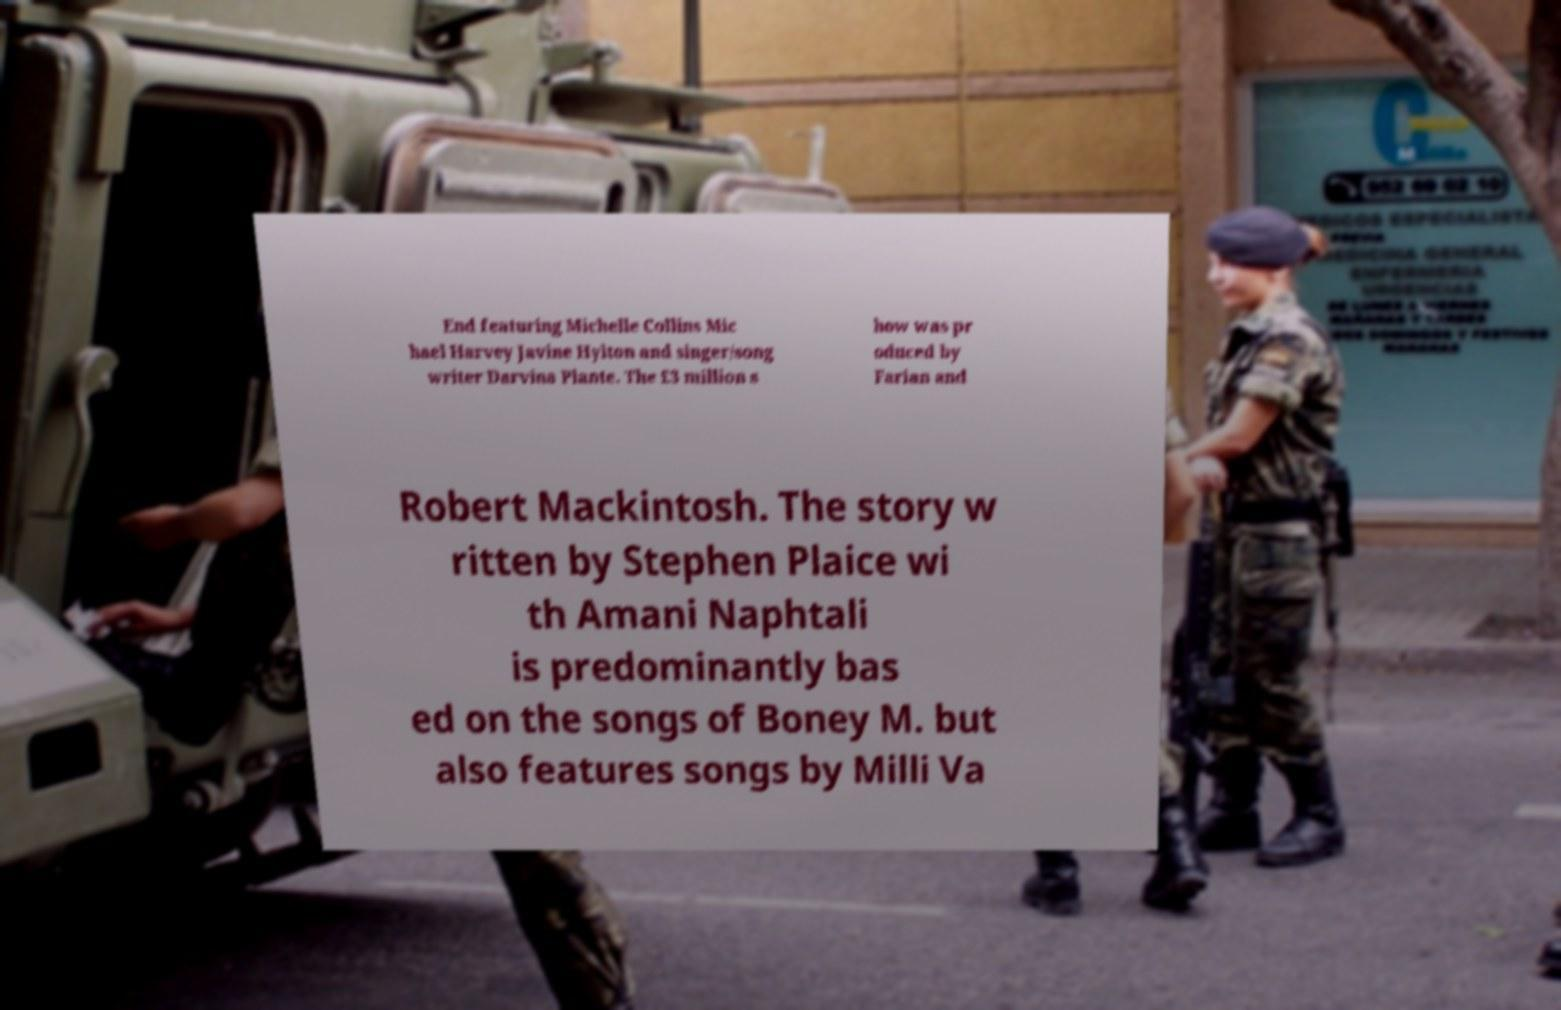For documentation purposes, I need the text within this image transcribed. Could you provide that? End featuring Michelle Collins Mic hael Harvey Javine Hylton and singer/song writer Darvina Plante. The £3 million s how was pr oduced by Farian and Robert Mackintosh. The story w ritten by Stephen Plaice wi th Amani Naphtali is predominantly bas ed on the songs of Boney M. but also features songs by Milli Va 